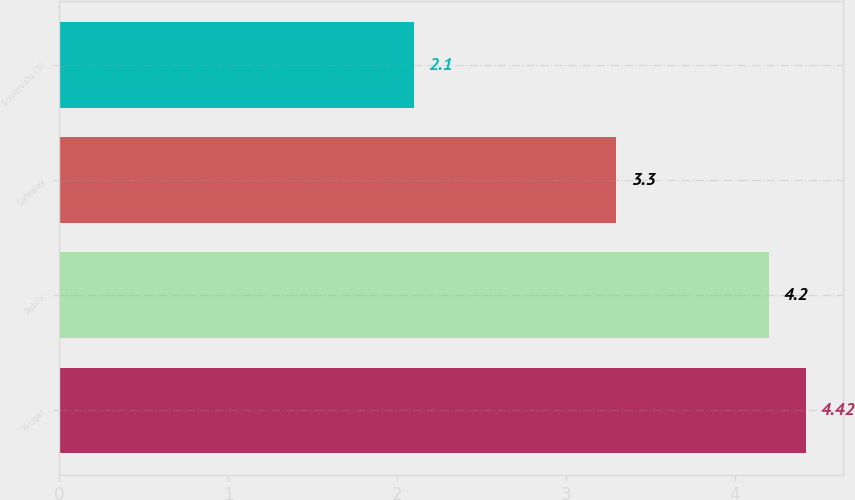<chart> <loc_0><loc_0><loc_500><loc_500><bar_chart><fcel>Kroger<fcel>Publix<fcel>Safeway<fcel>Supervalu (3)<nl><fcel>4.42<fcel>4.2<fcel>3.3<fcel>2.1<nl></chart> 